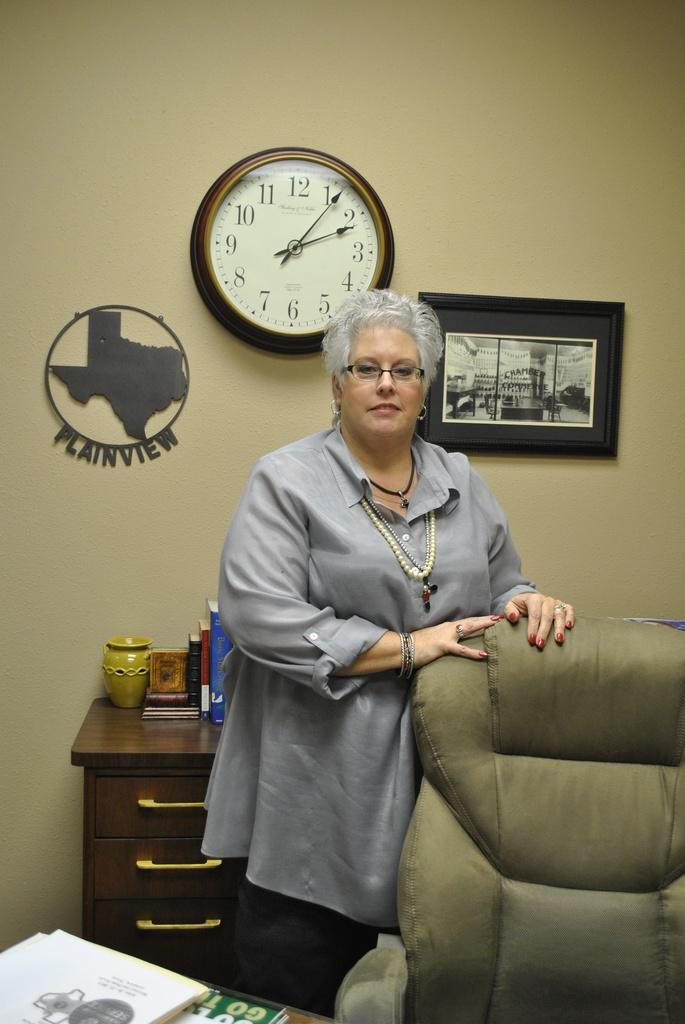<image>
Create a compact narrative representing the image presented. A woman stands in front of a plaque of Plainview and the state of Texas. 